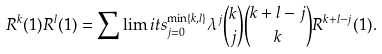<formula> <loc_0><loc_0><loc_500><loc_500>R ^ { k } ( 1 ) R ^ { l } ( 1 ) = \sum \lim i t s _ { j = 0 } ^ { \min \{ k , l \} } \lambda ^ { j } \binom { k } { j } \binom { k + l - j } { k } R ^ { k + l - j } ( 1 ) .</formula> 